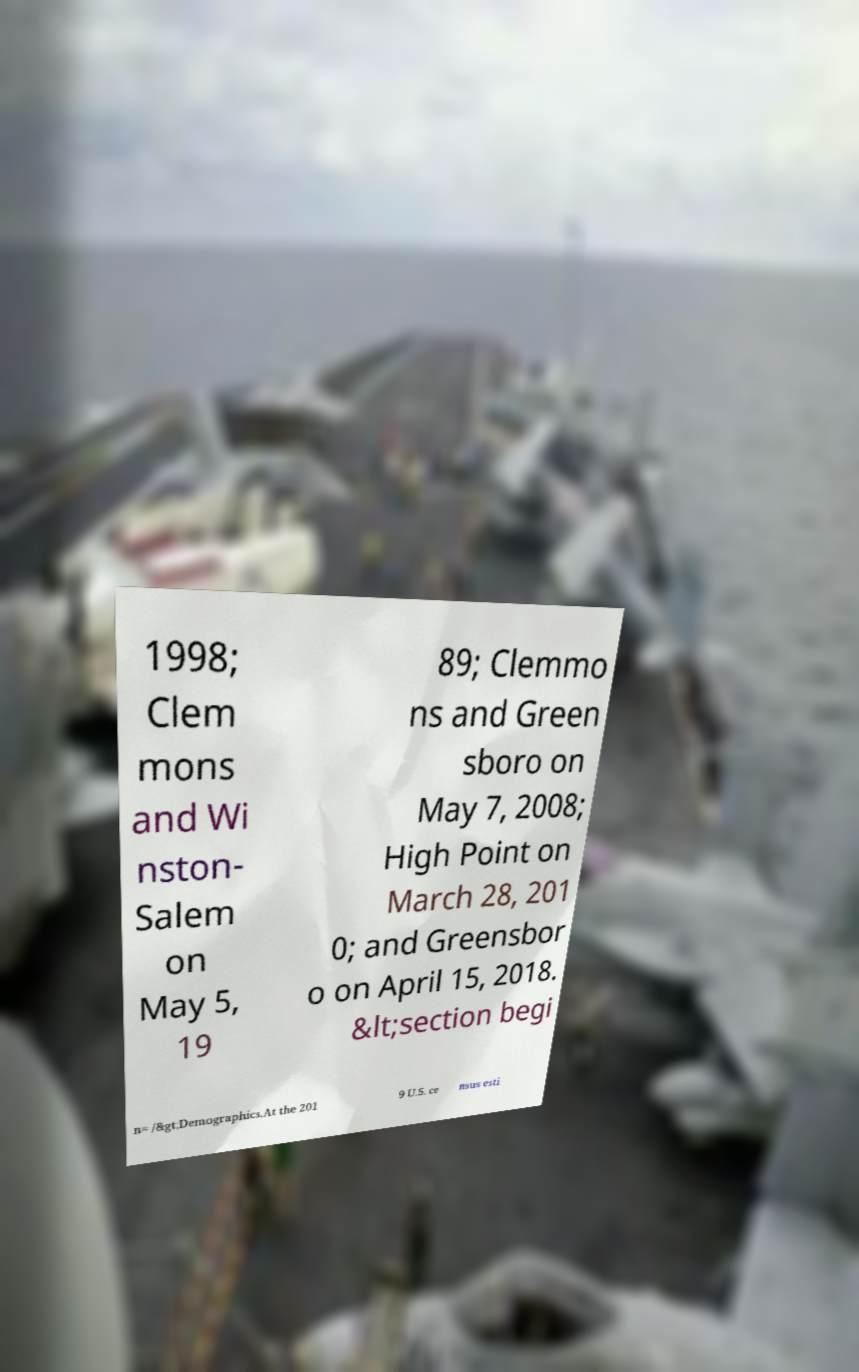Can you read and provide the text displayed in the image?This photo seems to have some interesting text. Can you extract and type it out for me? 1998; Clem mons and Wi nston- Salem on May 5, 19 89; Clemmo ns and Green sboro on May 7, 2008; High Point on March 28, 201 0; and Greensbor o on April 15, 2018. &lt;section begi n= /&gt;Demographics.At the 201 9 U.S. ce nsus esti 